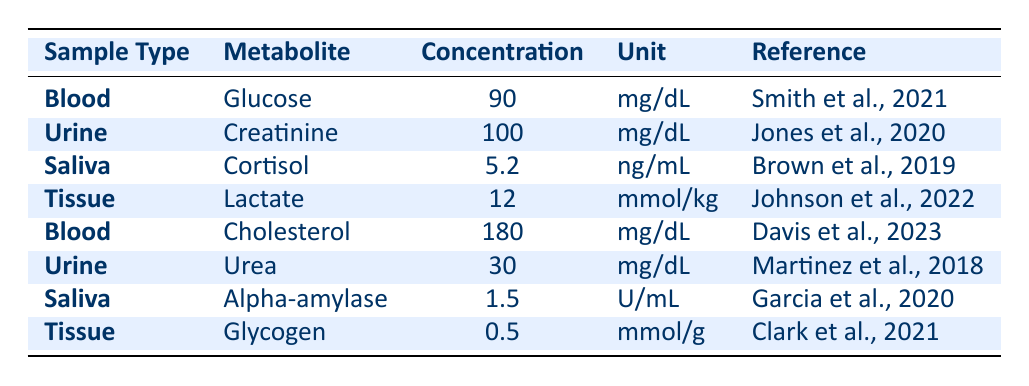What is the concentration of glucose in blood? The table shows the concentration of glucose in blood as 90 mg/dL.
Answer: 90 mg/dL What is the reference for the lactate concentration in tissue? The table indicates that the reference for lactate concentration in tissue is Johnson et al., 2022.
Answer: Johnson et al., 2022 Which sample type has the highest metabolite concentration? Comparing the concentrations, cholesterol in blood is 180 mg/dL, which is higher than all other listed concentrations.
Answer: Blood (Cholesterol - 180 mg/dL) What is the sum of the urea concentration from urine and creatinine concentration from urine? Urea concentration in urine is 30 mg/dL and creatinine concentration in urine is 100 mg/dL. Adding these gives 30 + 100 = 130 mg/dL.
Answer: 130 mg/dL Is the concentration of cortisol in saliva greater than 5 ng/mL? The table shows the cortisol concentration in saliva is exactly 5.2 ng/mL, which is greater than 5 ng/mL.
Answer: Yes What is the average concentration of metabolites in saliva? The concentrations in saliva are 5.2 ng/mL (cortisol) and 1.5 U/mL (alpha-amylase). To find the average, convert the units to a common basis for comparison, then find (5.2 + 1.5)/2. Since they are different units, we cannot calculate a standard average without conversion.
Answer: Not applicable What is the difference in concentration between cholesterol in blood and urea in urine? Cholesterol concentration in blood is 180 mg/dL and urea concentration in urine is 30 mg/dL. The difference is 180 - 30 = 150 mg/dL.
Answer: 150 mg/dL Which sample type has the lowest metabolite concentration, and what is the value? The metabolite with the lowest concentration is glycogen in tissue, which is 0.5 mmol/g.
Answer: Tissue (Glycogen - 0.5 mmol/g) 